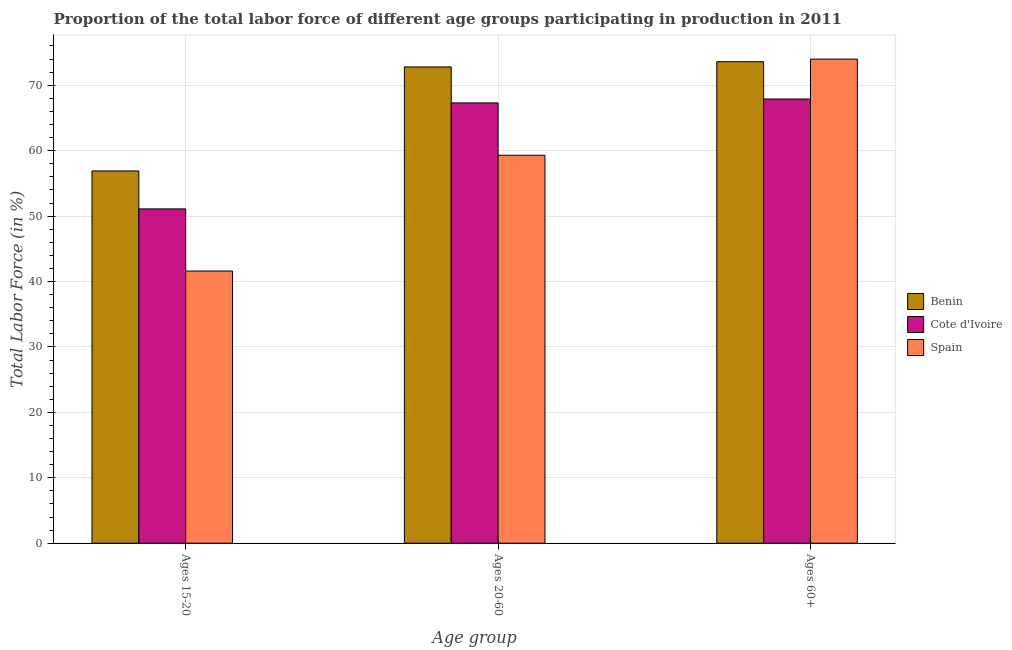Are the number of bars per tick equal to the number of legend labels?
Provide a short and direct response. Yes. How many bars are there on the 1st tick from the right?
Your response must be concise. 3. What is the label of the 2nd group of bars from the left?
Provide a succinct answer. Ages 20-60. What is the percentage of labor force above age 60 in Benin?
Offer a very short reply. 73.6. Across all countries, what is the minimum percentage of labor force within the age group 20-60?
Ensure brevity in your answer.  59.3. In which country was the percentage of labor force above age 60 maximum?
Give a very brief answer. Spain. In which country was the percentage of labor force within the age group 20-60 minimum?
Ensure brevity in your answer.  Spain. What is the total percentage of labor force within the age group 20-60 in the graph?
Your answer should be very brief. 199.4. What is the difference between the percentage of labor force above age 60 in Benin and that in Cote d'Ivoire?
Your answer should be compact. 5.7. What is the difference between the percentage of labor force within the age group 15-20 in Spain and the percentage of labor force within the age group 20-60 in Benin?
Make the answer very short. -31.2. What is the average percentage of labor force above age 60 per country?
Offer a very short reply. 71.83. What is the difference between the percentage of labor force within the age group 15-20 and percentage of labor force above age 60 in Cote d'Ivoire?
Make the answer very short. -16.8. In how many countries, is the percentage of labor force within the age group 20-60 greater than 38 %?
Give a very brief answer. 3. What is the ratio of the percentage of labor force within the age group 20-60 in Cote d'Ivoire to that in Spain?
Provide a short and direct response. 1.13. Is the percentage of labor force above age 60 in Cote d'Ivoire less than that in Spain?
Make the answer very short. Yes. What is the difference between the highest and the lowest percentage of labor force within the age group 15-20?
Keep it short and to the point. 15.3. In how many countries, is the percentage of labor force within the age group 15-20 greater than the average percentage of labor force within the age group 15-20 taken over all countries?
Your answer should be very brief. 2. Is the sum of the percentage of labor force within the age group 20-60 in Spain and Benin greater than the maximum percentage of labor force above age 60 across all countries?
Your response must be concise. Yes. What does the 2nd bar from the left in Ages 20-60 represents?
Keep it short and to the point. Cote d'Ivoire. What does the 2nd bar from the right in Ages 15-20 represents?
Your answer should be very brief. Cote d'Ivoire. Is it the case that in every country, the sum of the percentage of labor force within the age group 15-20 and percentage of labor force within the age group 20-60 is greater than the percentage of labor force above age 60?
Offer a terse response. Yes. Does the graph contain any zero values?
Give a very brief answer. No. Where does the legend appear in the graph?
Your response must be concise. Center right. How many legend labels are there?
Your answer should be compact. 3. How are the legend labels stacked?
Your answer should be compact. Vertical. What is the title of the graph?
Your answer should be compact. Proportion of the total labor force of different age groups participating in production in 2011. What is the label or title of the X-axis?
Make the answer very short. Age group. What is the Total Labor Force (in %) of Benin in Ages 15-20?
Offer a very short reply. 56.9. What is the Total Labor Force (in %) in Cote d'Ivoire in Ages 15-20?
Keep it short and to the point. 51.1. What is the Total Labor Force (in %) of Spain in Ages 15-20?
Ensure brevity in your answer.  41.6. What is the Total Labor Force (in %) in Benin in Ages 20-60?
Your answer should be very brief. 72.8. What is the Total Labor Force (in %) of Cote d'Ivoire in Ages 20-60?
Provide a succinct answer. 67.3. What is the Total Labor Force (in %) in Spain in Ages 20-60?
Offer a terse response. 59.3. What is the Total Labor Force (in %) of Benin in Ages 60+?
Your response must be concise. 73.6. What is the Total Labor Force (in %) in Cote d'Ivoire in Ages 60+?
Offer a very short reply. 67.9. Across all Age group, what is the maximum Total Labor Force (in %) of Benin?
Your answer should be compact. 73.6. Across all Age group, what is the maximum Total Labor Force (in %) in Cote d'Ivoire?
Offer a terse response. 67.9. Across all Age group, what is the minimum Total Labor Force (in %) in Benin?
Ensure brevity in your answer.  56.9. Across all Age group, what is the minimum Total Labor Force (in %) of Cote d'Ivoire?
Make the answer very short. 51.1. Across all Age group, what is the minimum Total Labor Force (in %) in Spain?
Your answer should be very brief. 41.6. What is the total Total Labor Force (in %) in Benin in the graph?
Give a very brief answer. 203.3. What is the total Total Labor Force (in %) in Cote d'Ivoire in the graph?
Make the answer very short. 186.3. What is the total Total Labor Force (in %) in Spain in the graph?
Your response must be concise. 174.9. What is the difference between the Total Labor Force (in %) in Benin in Ages 15-20 and that in Ages 20-60?
Keep it short and to the point. -15.9. What is the difference between the Total Labor Force (in %) in Cote d'Ivoire in Ages 15-20 and that in Ages 20-60?
Provide a short and direct response. -16.2. What is the difference between the Total Labor Force (in %) in Spain in Ages 15-20 and that in Ages 20-60?
Provide a succinct answer. -17.7. What is the difference between the Total Labor Force (in %) of Benin in Ages 15-20 and that in Ages 60+?
Your answer should be compact. -16.7. What is the difference between the Total Labor Force (in %) of Cote d'Ivoire in Ages 15-20 and that in Ages 60+?
Your response must be concise. -16.8. What is the difference between the Total Labor Force (in %) in Spain in Ages 15-20 and that in Ages 60+?
Offer a terse response. -32.4. What is the difference between the Total Labor Force (in %) in Spain in Ages 20-60 and that in Ages 60+?
Offer a terse response. -14.7. What is the difference between the Total Labor Force (in %) in Benin in Ages 15-20 and the Total Labor Force (in %) in Spain in Ages 60+?
Give a very brief answer. -17.1. What is the difference between the Total Labor Force (in %) of Cote d'Ivoire in Ages 15-20 and the Total Labor Force (in %) of Spain in Ages 60+?
Offer a very short reply. -22.9. What is the difference between the Total Labor Force (in %) in Benin in Ages 20-60 and the Total Labor Force (in %) in Cote d'Ivoire in Ages 60+?
Give a very brief answer. 4.9. What is the difference between the Total Labor Force (in %) in Benin in Ages 20-60 and the Total Labor Force (in %) in Spain in Ages 60+?
Your response must be concise. -1.2. What is the average Total Labor Force (in %) in Benin per Age group?
Keep it short and to the point. 67.77. What is the average Total Labor Force (in %) of Cote d'Ivoire per Age group?
Offer a very short reply. 62.1. What is the average Total Labor Force (in %) in Spain per Age group?
Provide a short and direct response. 58.3. What is the difference between the Total Labor Force (in %) in Benin and Total Labor Force (in %) in Spain in Ages 15-20?
Ensure brevity in your answer.  15.3. What is the difference between the Total Labor Force (in %) in Cote d'Ivoire and Total Labor Force (in %) in Spain in Ages 15-20?
Your answer should be compact. 9.5. What is the difference between the Total Labor Force (in %) of Benin and Total Labor Force (in %) of Cote d'Ivoire in Ages 20-60?
Your answer should be compact. 5.5. What is the difference between the Total Labor Force (in %) of Benin and Total Labor Force (in %) of Cote d'Ivoire in Ages 60+?
Offer a very short reply. 5.7. What is the difference between the Total Labor Force (in %) in Benin and Total Labor Force (in %) in Spain in Ages 60+?
Provide a short and direct response. -0.4. What is the ratio of the Total Labor Force (in %) in Benin in Ages 15-20 to that in Ages 20-60?
Ensure brevity in your answer.  0.78. What is the ratio of the Total Labor Force (in %) of Cote d'Ivoire in Ages 15-20 to that in Ages 20-60?
Offer a terse response. 0.76. What is the ratio of the Total Labor Force (in %) in Spain in Ages 15-20 to that in Ages 20-60?
Offer a very short reply. 0.7. What is the ratio of the Total Labor Force (in %) in Benin in Ages 15-20 to that in Ages 60+?
Your answer should be compact. 0.77. What is the ratio of the Total Labor Force (in %) of Cote d'Ivoire in Ages 15-20 to that in Ages 60+?
Make the answer very short. 0.75. What is the ratio of the Total Labor Force (in %) of Spain in Ages 15-20 to that in Ages 60+?
Give a very brief answer. 0.56. What is the ratio of the Total Labor Force (in %) of Cote d'Ivoire in Ages 20-60 to that in Ages 60+?
Provide a short and direct response. 0.99. What is the ratio of the Total Labor Force (in %) in Spain in Ages 20-60 to that in Ages 60+?
Your response must be concise. 0.8. What is the difference between the highest and the second highest Total Labor Force (in %) in Benin?
Offer a very short reply. 0.8. What is the difference between the highest and the second highest Total Labor Force (in %) in Spain?
Provide a short and direct response. 14.7. What is the difference between the highest and the lowest Total Labor Force (in %) in Cote d'Ivoire?
Give a very brief answer. 16.8. What is the difference between the highest and the lowest Total Labor Force (in %) in Spain?
Give a very brief answer. 32.4. 